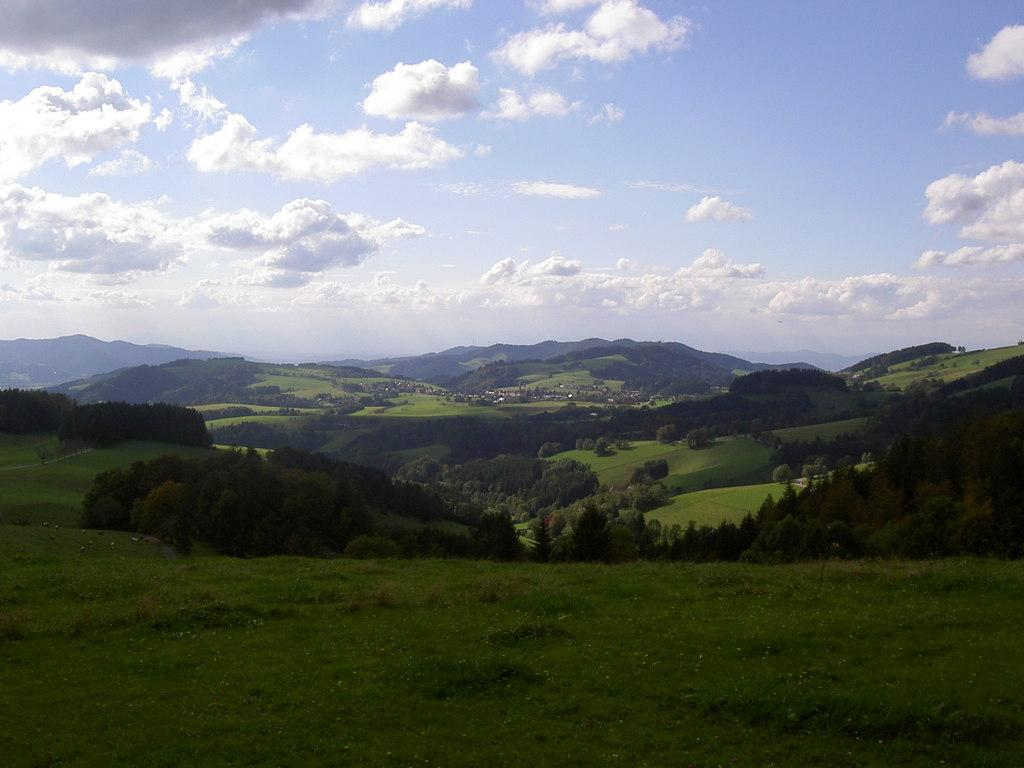What type of natural landform can be seen in the image? There are mountains in the image. What other natural elements are present in the image? There are trees and green grass in the image. What is visible in the background of the image? The sky is visible in the image. What colors can be seen in the sky? The sky has a combination of white and blue colors. How many geese are flying in the sky in the image? There are no geese present in the image; it only features mountains, trees, green grass, and the sky. What type of growth can be seen on the trees in the image? There is no specific growth mentioned or visible on the trees in the image; we can only see the trees themselves. 